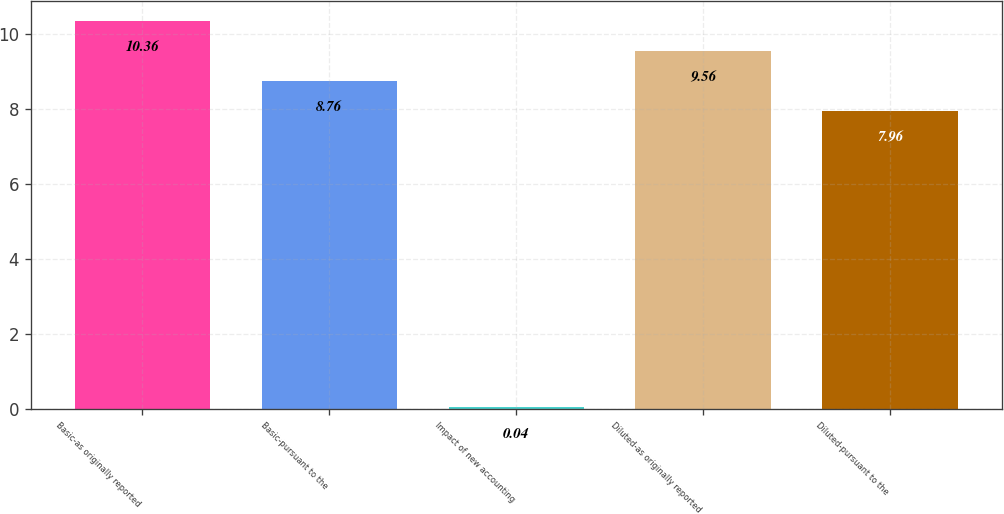<chart> <loc_0><loc_0><loc_500><loc_500><bar_chart><fcel>Basic-as originally reported<fcel>Basic-pursuant to the<fcel>Impact of new accounting<fcel>Diluted-as originally reported<fcel>Diluted-pursuant to the<nl><fcel>10.36<fcel>8.76<fcel>0.04<fcel>9.56<fcel>7.96<nl></chart> 